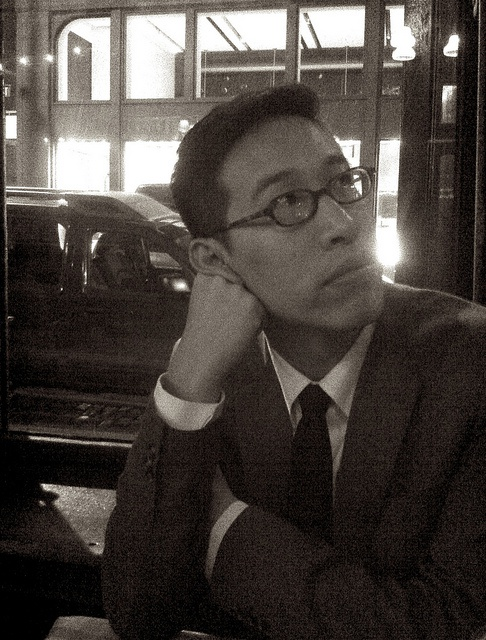Describe the objects in this image and their specific colors. I can see people in black and gray tones, car in black, gray, and darkgray tones, tie in black and gray tones, and people in black and gray tones in this image. 